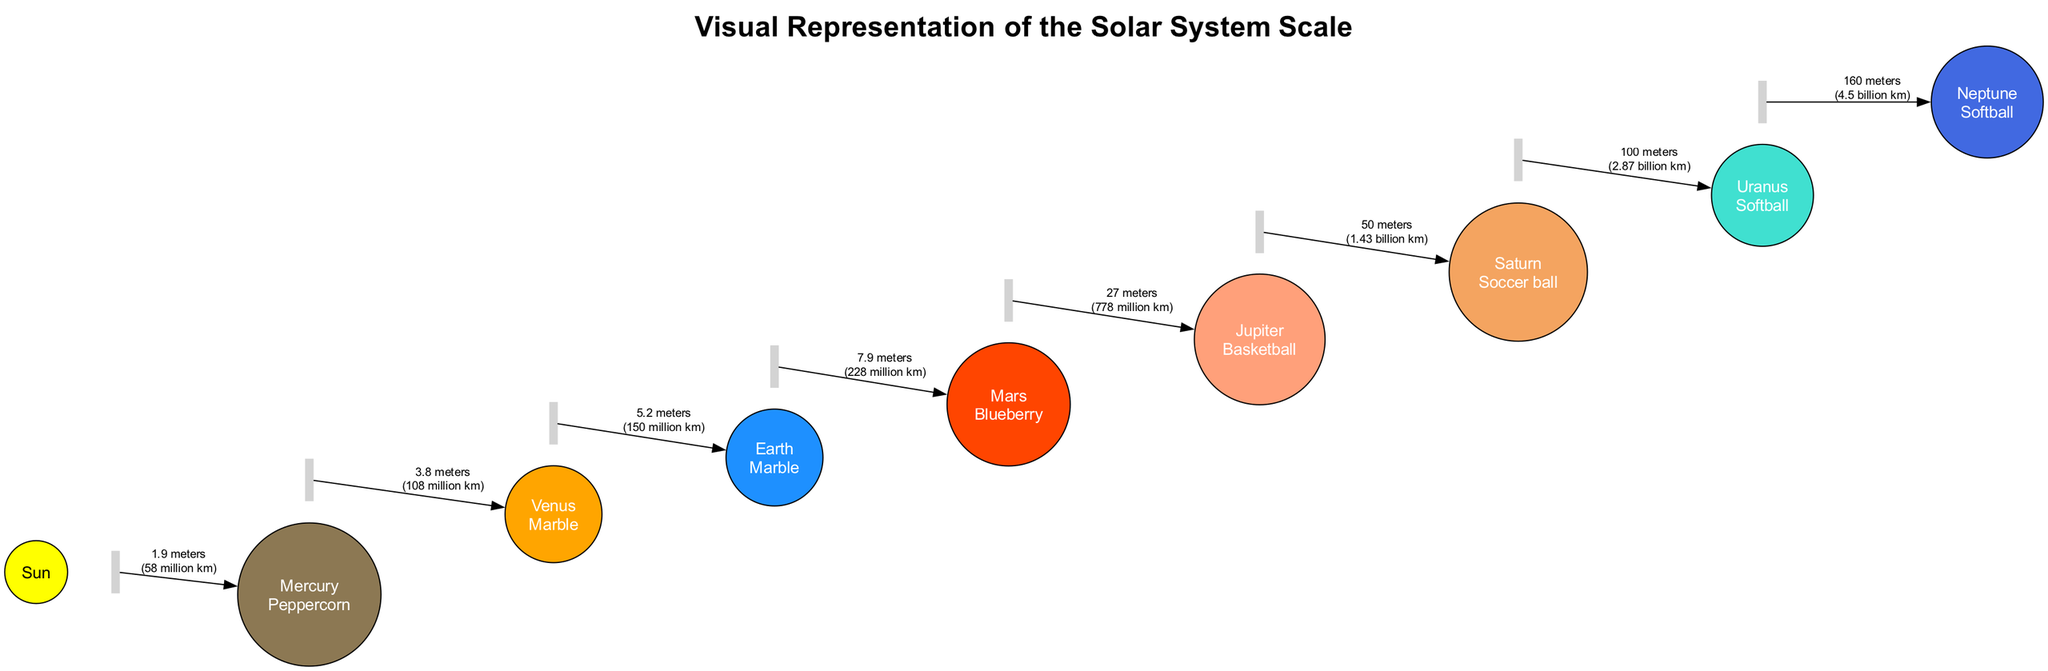What is the size comparison for Jupiter? According to the diagram, Jupiter is compared to a Basketball in terms of size.
Answer: Basketball What is the distance from the Sun to Neptune? The diagram indicates Neptune is 4.5 billion km away from the Sun.
Answer: 4.5 billion km Which planet's size is represented by a Blueberry? The diagram shows that Mars is represented by a Blueberry for its size comparison.
Answer: Mars How far is Venus from the Sun in meters? The graphic provides that Venus is 3.8 meters away from the Sun, as indicated in the distance comparison section.
Answer: 3.8 meters Which planets are represented by Softball in terms of size comparison? The diagram reveals that both Uranus and Neptune are represented as Softballs in size comparison.
Answer: Uranus and Neptune What is the relative distance comparison for Saturn? The distance comparison for Saturn is given as 50 meters from the Sun in the diagram.
Answer: 50 meters How many planets are listed in the diagram? By counting the elements in the diagram, we find there are eight planets listed.
Answer: Eight Which daily object is used to represent Mercury's size? Mercury's size is represented by a Peppercorn according to the diagram.
Answer: Peppercorn What is the smallest planet in terms of distance from the Sun? The smallest planet is Mercury, which is closest to the Sun at 58 million km away.
Answer: Mercury 